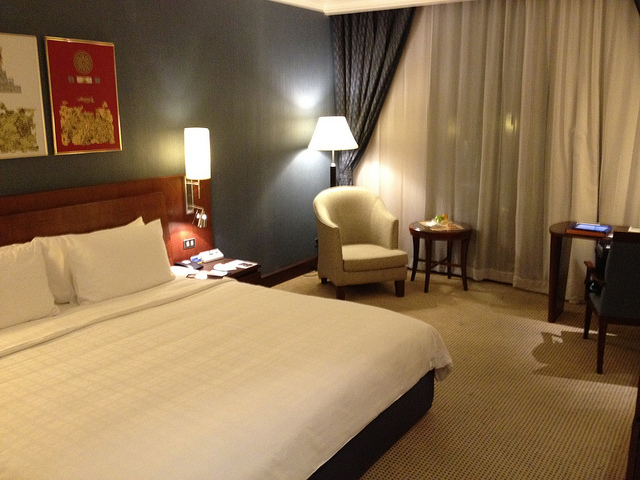What type of room is this? This appears to be a standard hotel room, furnished with a large bed, a nightstand, lamps, a chair, and a desk, which suggests comfortable accommodations for business or leisure travel. 